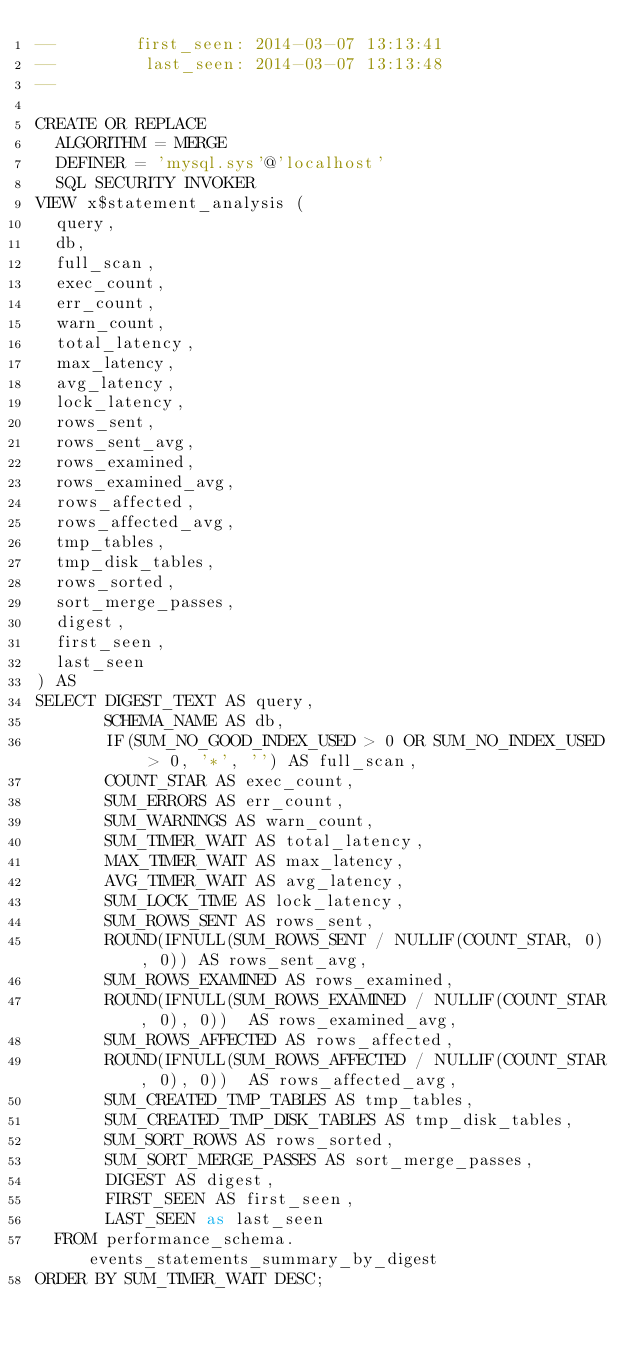<code> <loc_0><loc_0><loc_500><loc_500><_SQL_>--        first_seen: 2014-03-07 13:13:41
--         last_seen: 2014-03-07 13:13:48
--

CREATE OR REPLACE
  ALGORITHM = MERGE
  DEFINER = 'mysql.sys'@'localhost'
  SQL SECURITY INVOKER 
VIEW x$statement_analysis (
  query,
  db,
  full_scan,
  exec_count,
  err_count,
  warn_count,
  total_latency,
  max_latency,
  avg_latency,
  lock_latency,
  rows_sent,
  rows_sent_avg,
  rows_examined,
  rows_examined_avg,
  rows_affected,
  rows_affected_avg,
  tmp_tables,
  tmp_disk_tables,
  rows_sorted,
  sort_merge_passes,
  digest,
  first_seen,
  last_seen
) AS
SELECT DIGEST_TEXT AS query,
       SCHEMA_NAME AS db,
       IF(SUM_NO_GOOD_INDEX_USED > 0 OR SUM_NO_INDEX_USED > 0, '*', '') AS full_scan,
       COUNT_STAR AS exec_count,
       SUM_ERRORS AS err_count,
       SUM_WARNINGS AS warn_count,
       SUM_TIMER_WAIT AS total_latency,
       MAX_TIMER_WAIT AS max_latency,
       AVG_TIMER_WAIT AS avg_latency,
       SUM_LOCK_TIME AS lock_latency,
       SUM_ROWS_SENT AS rows_sent,
       ROUND(IFNULL(SUM_ROWS_SENT / NULLIF(COUNT_STAR, 0), 0)) AS rows_sent_avg,
       SUM_ROWS_EXAMINED AS rows_examined,
       ROUND(IFNULL(SUM_ROWS_EXAMINED / NULLIF(COUNT_STAR, 0), 0))  AS rows_examined_avg,
       SUM_ROWS_AFFECTED AS rows_affected,
       ROUND(IFNULL(SUM_ROWS_AFFECTED / NULLIF(COUNT_STAR, 0), 0))  AS rows_affected_avg,
       SUM_CREATED_TMP_TABLES AS tmp_tables,
       SUM_CREATED_TMP_DISK_TABLES AS tmp_disk_tables,
       SUM_SORT_ROWS AS rows_sorted,
       SUM_SORT_MERGE_PASSES AS sort_merge_passes,
       DIGEST AS digest,
       FIRST_SEEN AS first_seen,
       LAST_SEEN as last_seen
  FROM performance_schema.events_statements_summary_by_digest
ORDER BY SUM_TIMER_WAIT DESC;
</code> 